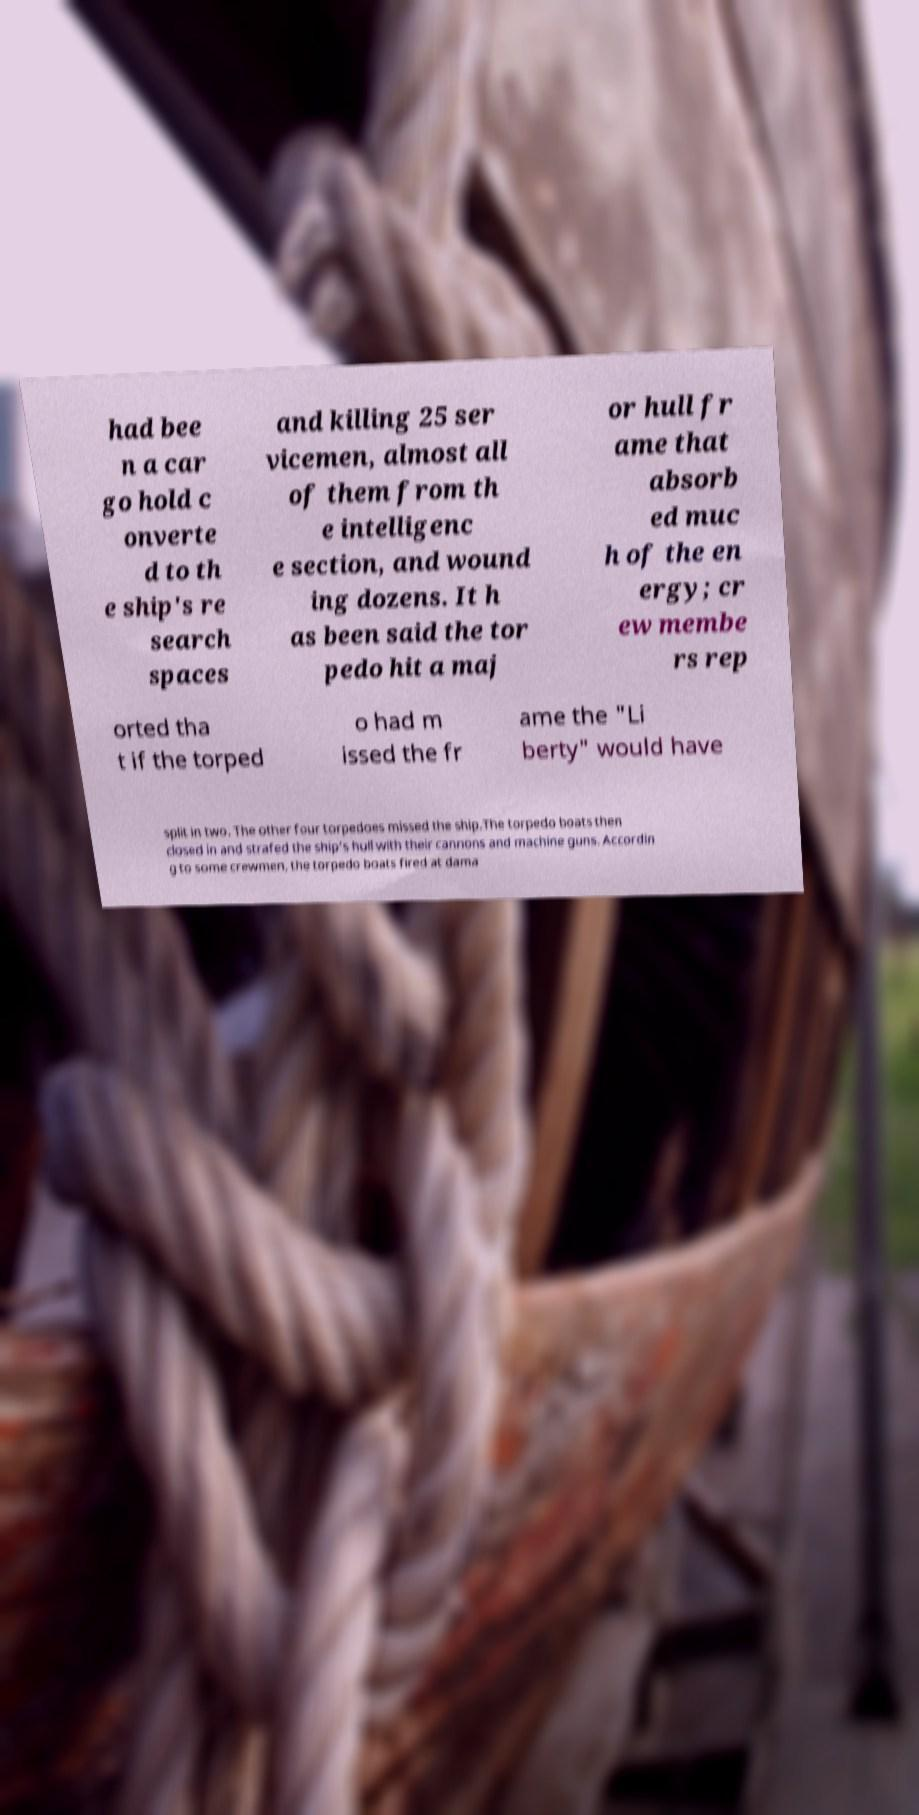What messages or text are displayed in this image? I need them in a readable, typed format. had bee n a car go hold c onverte d to th e ship's re search spaces and killing 25 ser vicemen, almost all of them from th e intelligenc e section, and wound ing dozens. It h as been said the tor pedo hit a maj or hull fr ame that absorb ed muc h of the en ergy; cr ew membe rs rep orted tha t if the torped o had m issed the fr ame the "Li berty" would have split in two. The other four torpedoes missed the ship.The torpedo boats then closed in and strafed the ship's hull with their cannons and machine guns. Accordin g to some crewmen, the torpedo boats fired at dama 